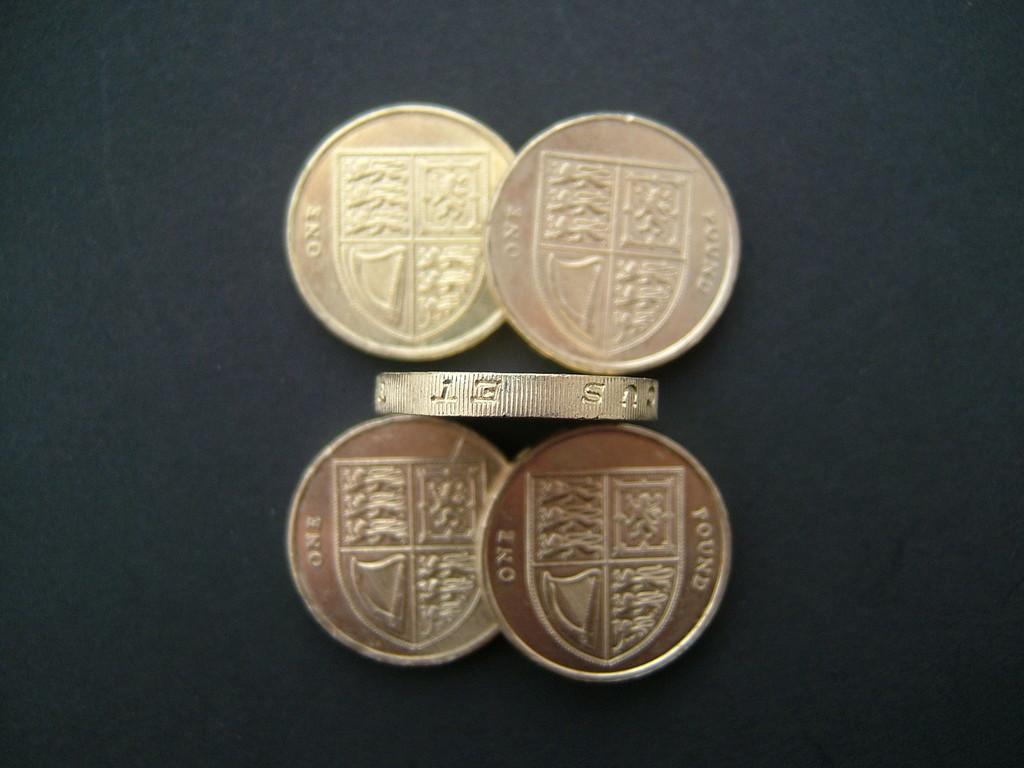What type of coins are these?
Offer a very short reply. One pound. How much is each coin worth?
Offer a very short reply. One pound. 